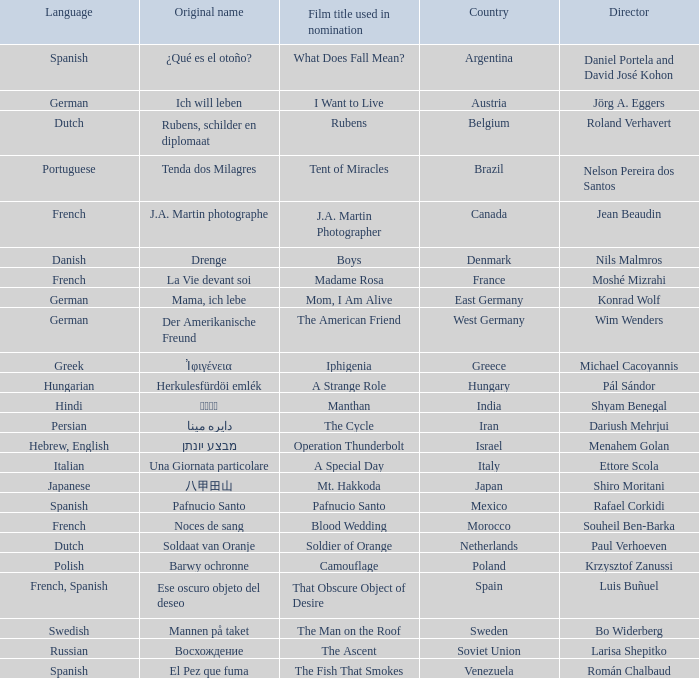Which country is the director Roland Verhavert from? Belgium. 